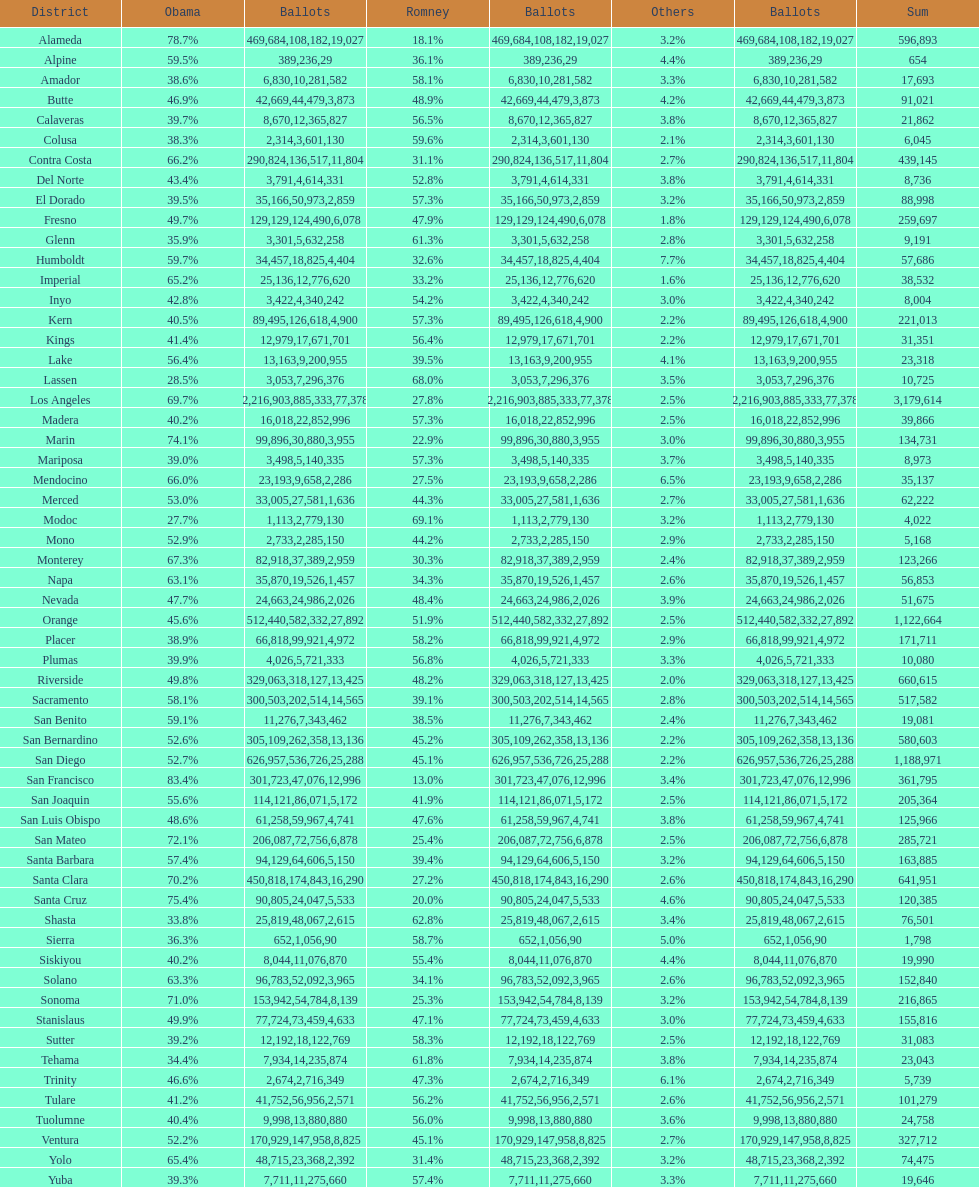What county is just before del norte on the list? Contra Costa. 